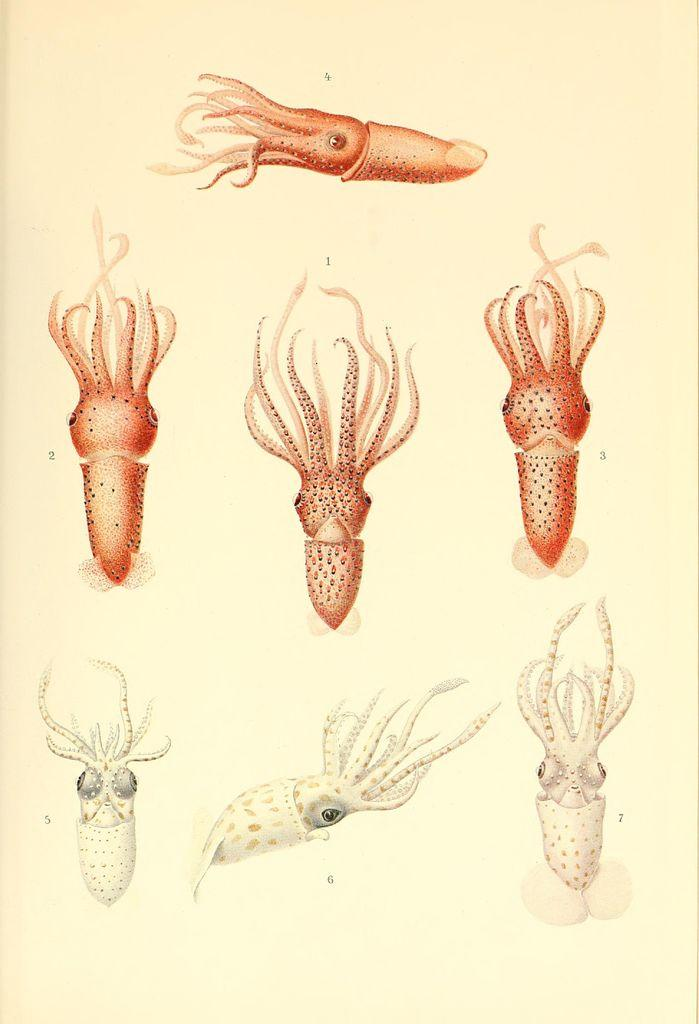What is the main subject of the image? The main subject of the image is an octopus. What type of drawing is the image? The image is a sketch. How many crows are sitting on the octopus's head in the image? There are no crows present in the image; it is a sketch of an octopus. What type of mark can be seen on the octopus's tentacle in the image? There is no specific mark mentioned on the octopus's tentacle in the provided facts, and the image is a sketch, so it may not have any distinct marks. 